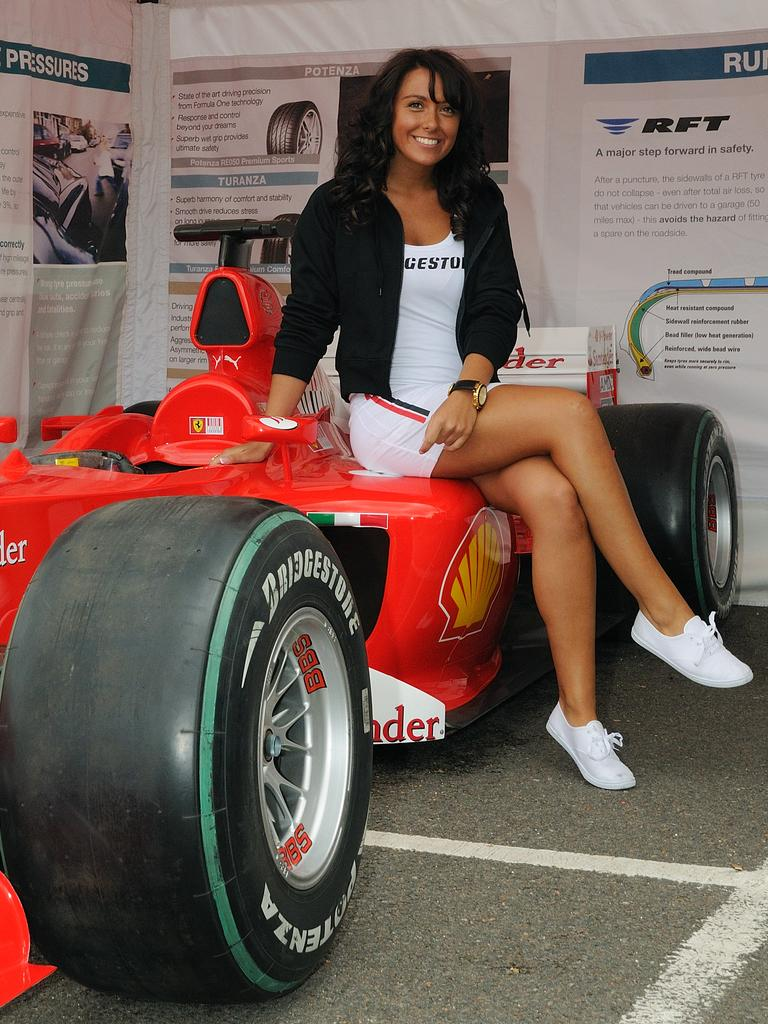What is present in the image? There is a person in the image. Can you describe what the person is wearing? The person is wearing clothes. What is the person doing in the image? The person is sitting on a car. Can you see any ants crawling on the person's clothes in the image? There are no ants visible on the person's clothes in the image. What type of yak can be seen grazing in the background of the image? There is no yak present in the image; it only features a person sitting on a car. 